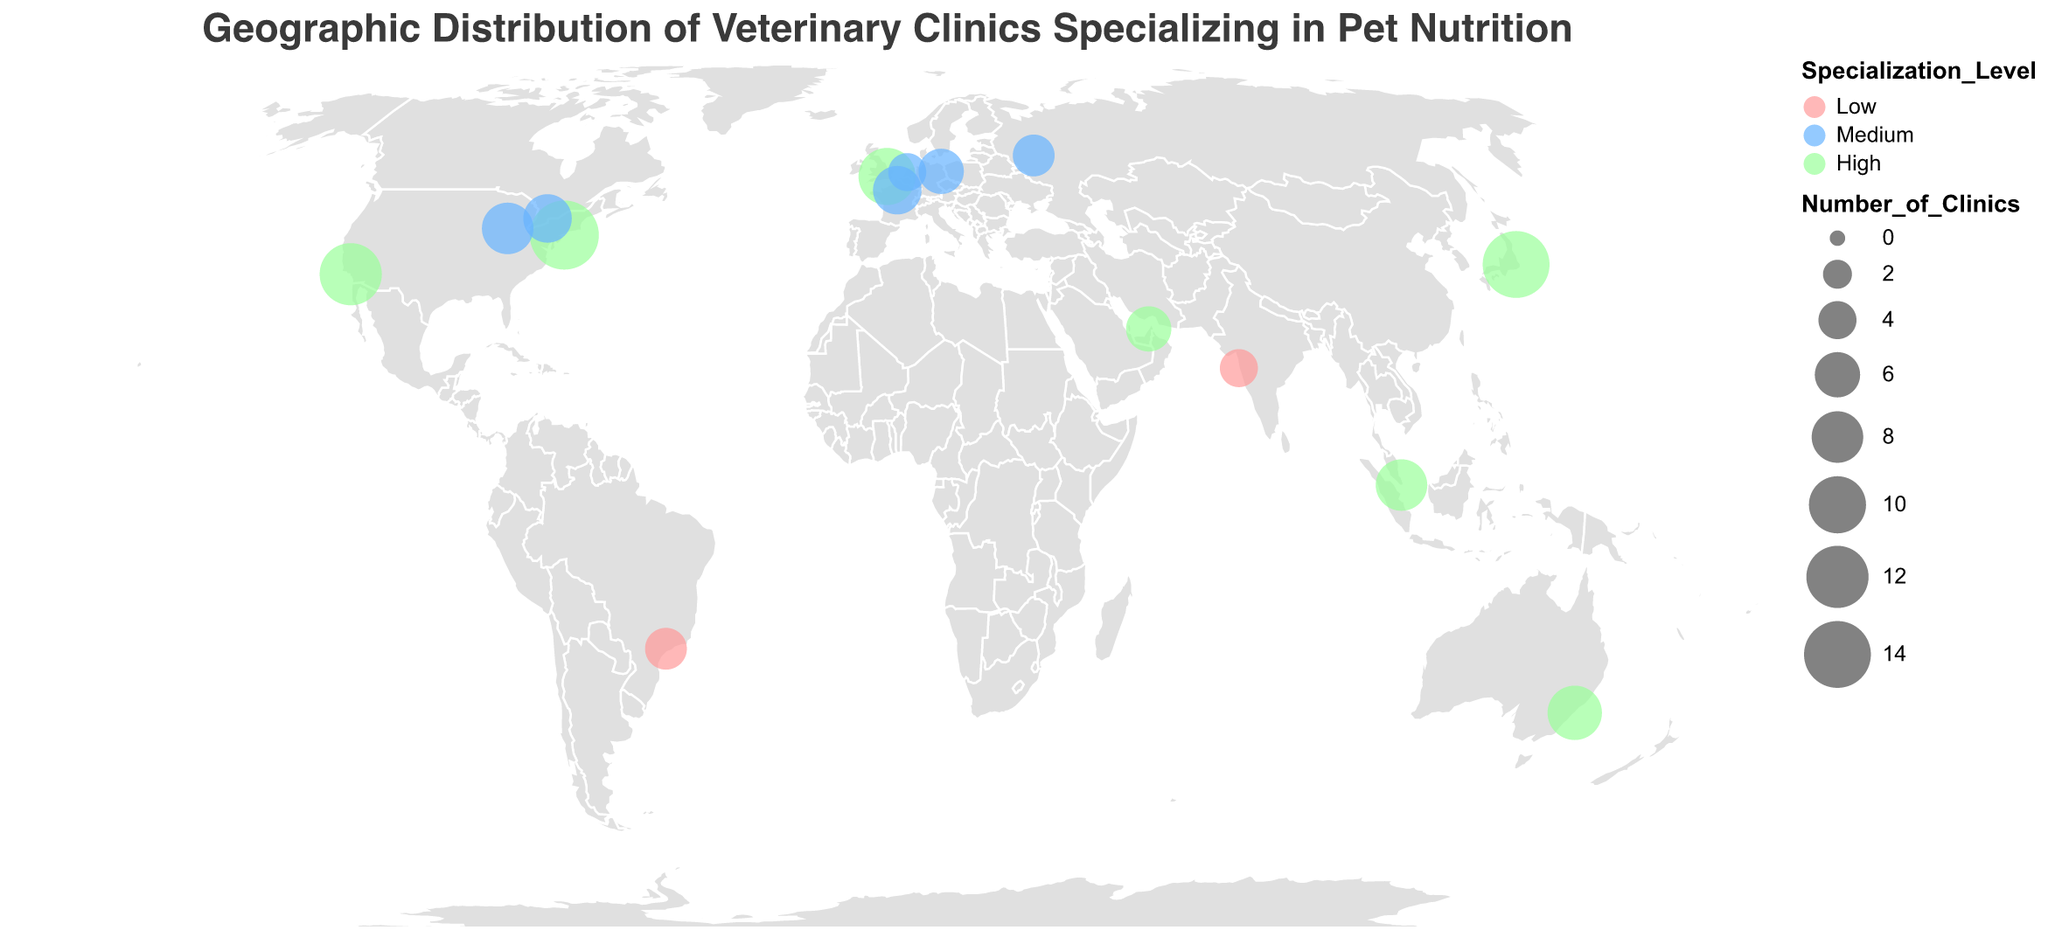How many cities have veterinary clinics with a "High" specialization level? The map uses different colors to indicate specialization levels. Count the number of circles that are colored in the shade representing "High" specialization level.
Answer: 8 Which city has the largest number of veterinary clinics? The sizes of the circles represent the number of clinics. Identify the largest circle and note the associated city's name.
Answer: New York City What is the total number of veterinary clinics in cities with a "Medium" specialization level? Identify the circles with the color representing "Medium" specialization, extract the number of clinics from each, and sum them up.
Answer: 39 (Chicago: 8, Paris: 7, Berlin: 6, Toronto: 7, Moscow: 5, Amsterdam: 4) Which city has the smallest number of veterinary clinics, and what is that number? Identify the smallest circle on the map and look at the tooltip or data shown for that circle.
Answer: Mumbai, 4 Do more cities have "High" or "Low" specialization levels? Count the number of cities with "High" specialization and the number of cities with "Low" specialization, and compare the two counts.
Answer: High Among the cities with a "Low" specialization level, which city is located in the Northern Hemisphere? Identify the cities with a "Low" specialization level and look at their latitudes to see if they fall above the equator (positive latitude values).
Answer: São Paulo Which regions of the world have the highest density of veterinary clinics specializing in pet nutrition (based on visual observation)? Observe the geographic distribution and concentration of the circles to determine where most circles are located.
Answer: North America and East Asia How does the number of veterinary clinics in Tokyo compare to those in Sydney? Identify the circles for Tokyo and Sydney, check their sizes or tooltips for number of clinics, and compare the two.
Answer: Tokyo has 14 clinics, while Sydney has 9. Tokyo has more clinics What is the average number of veterinary clinics across all the cities mentioned? Sum the number of clinics for all cities and divide by the total number of cities. (15+12+8+10+7+6+14+9+7+5+4+6+8+5+4) / 15 = 6.87
Answer: 6.87 